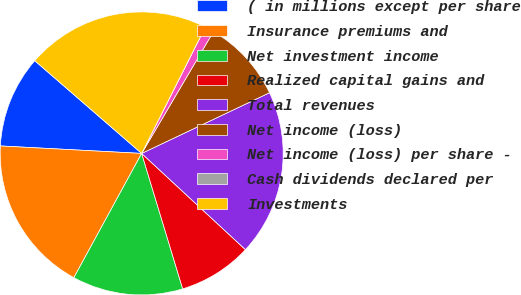<chart> <loc_0><loc_0><loc_500><loc_500><pie_chart><fcel>( in millions except per share<fcel>Insurance premiums and<fcel>Net investment income<fcel>Realized capital gains and<fcel>Total revenues<fcel>Net income (loss)<fcel>Net income (loss) per share -<fcel>Cash dividends declared per<fcel>Investments<nl><fcel>10.53%<fcel>17.89%<fcel>12.63%<fcel>8.42%<fcel>18.95%<fcel>9.47%<fcel>1.05%<fcel>0.0%<fcel>21.05%<nl></chart> 